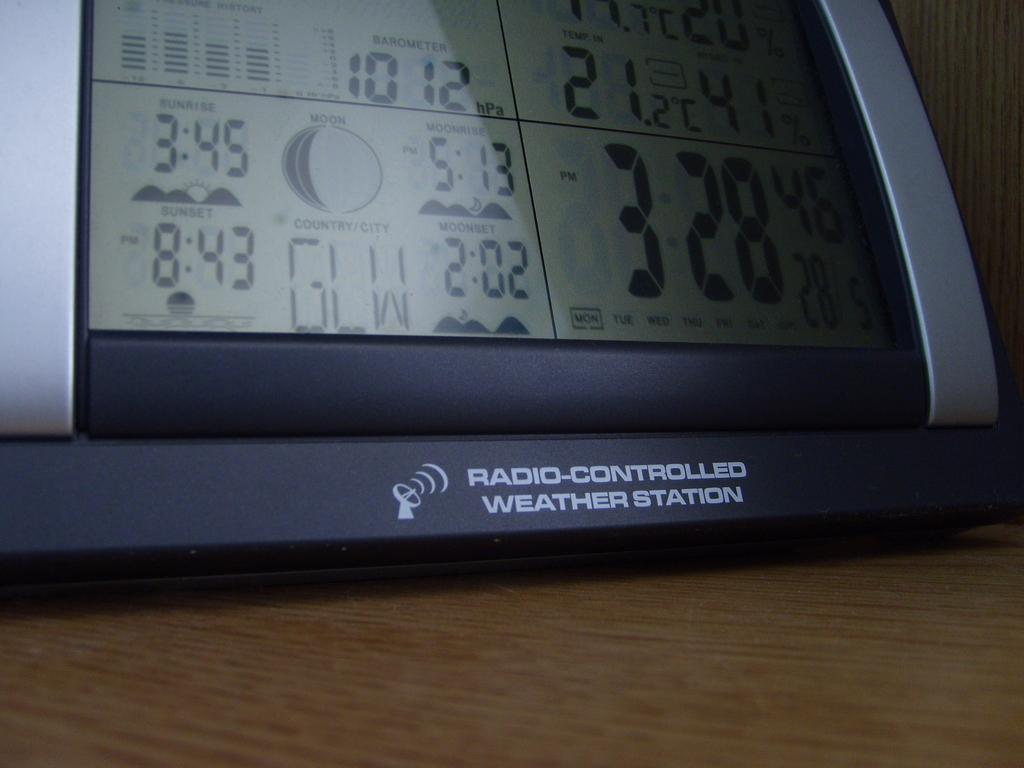<image>
Offer a succinct explanation of the picture presented. A radio-controlled weather station indicated the sunset time of 8:43/ 